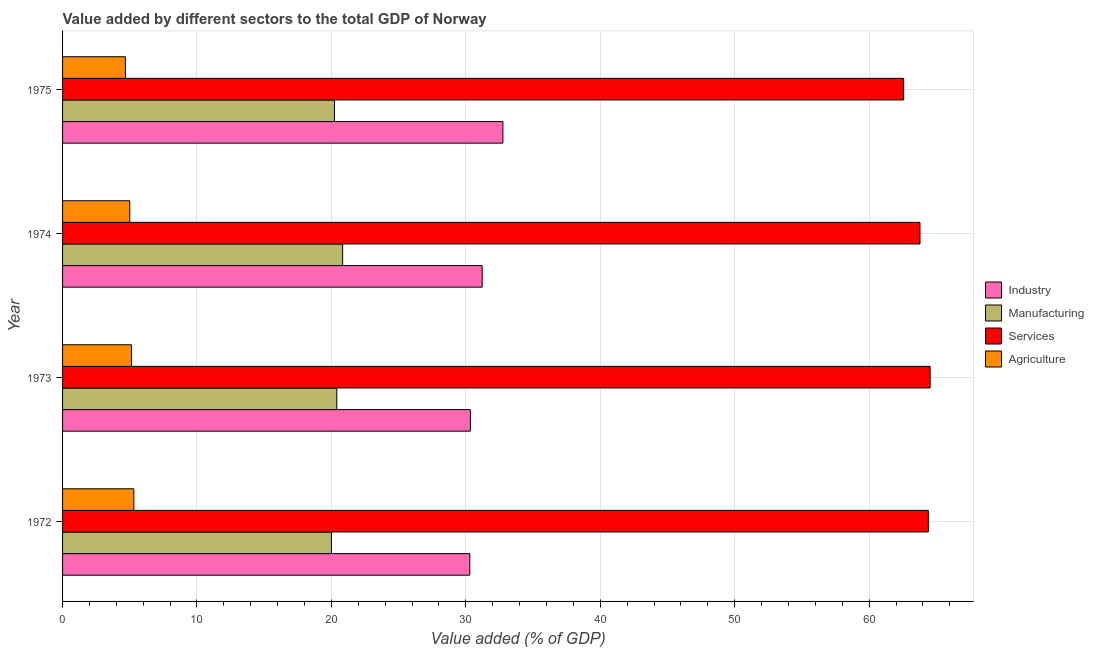How many groups of bars are there?
Provide a succinct answer. 4. Are the number of bars per tick equal to the number of legend labels?
Offer a terse response. Yes. Are the number of bars on each tick of the Y-axis equal?
Offer a very short reply. Yes. What is the label of the 1st group of bars from the top?
Give a very brief answer. 1975. In how many cases, is the number of bars for a given year not equal to the number of legend labels?
Your answer should be compact. 0. What is the value added by services sector in 1974?
Give a very brief answer. 63.79. Across all years, what is the maximum value added by agricultural sector?
Your answer should be very brief. 5.3. Across all years, what is the minimum value added by services sector?
Offer a terse response. 62.57. In which year was the value added by industrial sector maximum?
Provide a short and direct response. 1975. In which year was the value added by agricultural sector minimum?
Your response must be concise. 1975. What is the total value added by manufacturing sector in the graph?
Offer a terse response. 81.47. What is the difference between the value added by industrial sector in 1972 and that in 1975?
Offer a very short reply. -2.46. What is the difference between the value added by agricultural sector in 1973 and the value added by services sector in 1975?
Offer a terse response. -57.44. What is the average value added by services sector per year?
Your response must be concise. 63.83. In the year 1974, what is the difference between the value added by industrial sector and value added by agricultural sector?
Your response must be concise. 26.22. In how many years, is the value added by services sector greater than 50 %?
Provide a short and direct response. 4. Is the value added by services sector in 1974 less than that in 1975?
Provide a succinct answer. No. Is the difference between the value added by manufacturing sector in 1973 and 1975 greater than the difference between the value added by services sector in 1973 and 1975?
Offer a very short reply. No. What is the difference between the highest and the second highest value added by agricultural sector?
Make the answer very short. 0.18. What is the difference between the highest and the lowest value added by services sector?
Your answer should be compact. 1.97. In how many years, is the value added by manufacturing sector greater than the average value added by manufacturing sector taken over all years?
Provide a short and direct response. 2. Is the sum of the value added by agricultural sector in 1972 and 1974 greater than the maximum value added by manufacturing sector across all years?
Offer a terse response. No. What does the 4th bar from the top in 1972 represents?
Give a very brief answer. Industry. What does the 1st bar from the bottom in 1973 represents?
Give a very brief answer. Industry. How many bars are there?
Provide a short and direct response. 16. What is the difference between two consecutive major ticks on the X-axis?
Give a very brief answer. 10. Are the values on the major ticks of X-axis written in scientific E-notation?
Make the answer very short. No. Where does the legend appear in the graph?
Ensure brevity in your answer.  Center right. How are the legend labels stacked?
Provide a short and direct response. Vertical. What is the title of the graph?
Make the answer very short. Value added by different sectors to the total GDP of Norway. What is the label or title of the X-axis?
Keep it short and to the point. Value added (% of GDP). What is the Value added (% of GDP) of Industry in 1972?
Your answer should be very brief. 30.29. What is the Value added (% of GDP) in Manufacturing in 1972?
Make the answer very short. 20. What is the Value added (% of GDP) in Services in 1972?
Your answer should be very brief. 64.41. What is the Value added (% of GDP) of Agriculture in 1972?
Make the answer very short. 5.3. What is the Value added (% of GDP) of Industry in 1973?
Offer a very short reply. 30.34. What is the Value added (% of GDP) in Manufacturing in 1973?
Make the answer very short. 20.4. What is the Value added (% of GDP) in Services in 1973?
Provide a succinct answer. 64.54. What is the Value added (% of GDP) of Agriculture in 1973?
Provide a succinct answer. 5.12. What is the Value added (% of GDP) in Industry in 1974?
Your answer should be very brief. 31.22. What is the Value added (% of GDP) in Manufacturing in 1974?
Your response must be concise. 20.83. What is the Value added (% of GDP) in Services in 1974?
Ensure brevity in your answer.  63.79. What is the Value added (% of GDP) of Agriculture in 1974?
Offer a very short reply. 5. What is the Value added (% of GDP) in Industry in 1975?
Ensure brevity in your answer.  32.76. What is the Value added (% of GDP) in Manufacturing in 1975?
Provide a succinct answer. 20.23. What is the Value added (% of GDP) of Services in 1975?
Your response must be concise. 62.57. What is the Value added (% of GDP) in Agriculture in 1975?
Make the answer very short. 4.67. Across all years, what is the maximum Value added (% of GDP) in Industry?
Offer a terse response. 32.76. Across all years, what is the maximum Value added (% of GDP) in Manufacturing?
Make the answer very short. 20.83. Across all years, what is the maximum Value added (% of GDP) of Services?
Ensure brevity in your answer.  64.54. Across all years, what is the maximum Value added (% of GDP) in Agriculture?
Provide a succinct answer. 5.3. Across all years, what is the minimum Value added (% of GDP) of Industry?
Offer a terse response. 30.29. Across all years, what is the minimum Value added (% of GDP) of Manufacturing?
Your answer should be very brief. 20. Across all years, what is the minimum Value added (% of GDP) of Services?
Make the answer very short. 62.57. Across all years, what is the minimum Value added (% of GDP) in Agriculture?
Your response must be concise. 4.67. What is the total Value added (% of GDP) in Industry in the graph?
Ensure brevity in your answer.  124.6. What is the total Value added (% of GDP) of Manufacturing in the graph?
Your response must be concise. 81.47. What is the total Value added (% of GDP) in Services in the graph?
Make the answer very short. 255.3. What is the total Value added (% of GDP) of Agriculture in the graph?
Keep it short and to the point. 20.1. What is the difference between the Value added (% of GDP) of Industry in 1972 and that in 1973?
Keep it short and to the point. -0.04. What is the difference between the Value added (% of GDP) in Manufacturing in 1972 and that in 1973?
Give a very brief answer. -0.4. What is the difference between the Value added (% of GDP) in Services in 1972 and that in 1973?
Give a very brief answer. -0.13. What is the difference between the Value added (% of GDP) of Agriculture in 1972 and that in 1973?
Provide a short and direct response. 0.18. What is the difference between the Value added (% of GDP) of Industry in 1972 and that in 1974?
Your answer should be compact. -0.92. What is the difference between the Value added (% of GDP) in Manufacturing in 1972 and that in 1974?
Provide a short and direct response. -0.83. What is the difference between the Value added (% of GDP) in Services in 1972 and that in 1974?
Make the answer very short. 0.62. What is the difference between the Value added (% of GDP) in Agriculture in 1972 and that in 1974?
Your response must be concise. 0.3. What is the difference between the Value added (% of GDP) in Industry in 1972 and that in 1975?
Give a very brief answer. -2.46. What is the difference between the Value added (% of GDP) in Manufacturing in 1972 and that in 1975?
Keep it short and to the point. -0.22. What is the difference between the Value added (% of GDP) in Services in 1972 and that in 1975?
Your answer should be compact. 1.84. What is the difference between the Value added (% of GDP) in Agriculture in 1972 and that in 1975?
Provide a succinct answer. 0.63. What is the difference between the Value added (% of GDP) of Industry in 1973 and that in 1974?
Offer a terse response. -0.88. What is the difference between the Value added (% of GDP) of Manufacturing in 1973 and that in 1974?
Make the answer very short. -0.43. What is the difference between the Value added (% of GDP) of Services in 1973 and that in 1974?
Make the answer very short. 0.75. What is the difference between the Value added (% of GDP) in Agriculture in 1973 and that in 1974?
Make the answer very short. 0.12. What is the difference between the Value added (% of GDP) of Industry in 1973 and that in 1975?
Give a very brief answer. -2.42. What is the difference between the Value added (% of GDP) of Manufacturing in 1973 and that in 1975?
Ensure brevity in your answer.  0.17. What is the difference between the Value added (% of GDP) of Services in 1973 and that in 1975?
Your answer should be very brief. 1.97. What is the difference between the Value added (% of GDP) in Agriculture in 1973 and that in 1975?
Provide a succinct answer. 0.45. What is the difference between the Value added (% of GDP) of Industry in 1974 and that in 1975?
Your answer should be very brief. -1.54. What is the difference between the Value added (% of GDP) in Manufacturing in 1974 and that in 1975?
Offer a very short reply. 0.61. What is the difference between the Value added (% of GDP) in Services in 1974 and that in 1975?
Make the answer very short. 1.22. What is the difference between the Value added (% of GDP) of Agriculture in 1974 and that in 1975?
Your response must be concise. 0.32. What is the difference between the Value added (% of GDP) in Industry in 1972 and the Value added (% of GDP) in Manufacturing in 1973?
Your response must be concise. 9.89. What is the difference between the Value added (% of GDP) of Industry in 1972 and the Value added (% of GDP) of Services in 1973?
Your response must be concise. -34.25. What is the difference between the Value added (% of GDP) of Industry in 1972 and the Value added (% of GDP) of Agriculture in 1973?
Your answer should be very brief. 25.17. What is the difference between the Value added (% of GDP) of Manufacturing in 1972 and the Value added (% of GDP) of Services in 1973?
Offer a terse response. -44.54. What is the difference between the Value added (% of GDP) in Manufacturing in 1972 and the Value added (% of GDP) in Agriculture in 1973?
Provide a short and direct response. 14.88. What is the difference between the Value added (% of GDP) of Services in 1972 and the Value added (% of GDP) of Agriculture in 1973?
Ensure brevity in your answer.  59.28. What is the difference between the Value added (% of GDP) in Industry in 1972 and the Value added (% of GDP) in Manufacturing in 1974?
Keep it short and to the point. 9.46. What is the difference between the Value added (% of GDP) of Industry in 1972 and the Value added (% of GDP) of Services in 1974?
Provide a succinct answer. -33.49. What is the difference between the Value added (% of GDP) in Industry in 1972 and the Value added (% of GDP) in Agriculture in 1974?
Offer a very short reply. 25.29. What is the difference between the Value added (% of GDP) in Manufacturing in 1972 and the Value added (% of GDP) in Services in 1974?
Your answer should be compact. -43.78. What is the difference between the Value added (% of GDP) in Manufacturing in 1972 and the Value added (% of GDP) in Agriculture in 1974?
Ensure brevity in your answer.  15. What is the difference between the Value added (% of GDP) of Services in 1972 and the Value added (% of GDP) of Agriculture in 1974?
Provide a succinct answer. 59.41. What is the difference between the Value added (% of GDP) of Industry in 1972 and the Value added (% of GDP) of Manufacturing in 1975?
Provide a short and direct response. 10.07. What is the difference between the Value added (% of GDP) of Industry in 1972 and the Value added (% of GDP) of Services in 1975?
Keep it short and to the point. -32.27. What is the difference between the Value added (% of GDP) in Industry in 1972 and the Value added (% of GDP) in Agriculture in 1975?
Ensure brevity in your answer.  25.62. What is the difference between the Value added (% of GDP) of Manufacturing in 1972 and the Value added (% of GDP) of Services in 1975?
Give a very brief answer. -42.56. What is the difference between the Value added (% of GDP) in Manufacturing in 1972 and the Value added (% of GDP) in Agriculture in 1975?
Your response must be concise. 15.33. What is the difference between the Value added (% of GDP) of Services in 1972 and the Value added (% of GDP) of Agriculture in 1975?
Your answer should be compact. 59.73. What is the difference between the Value added (% of GDP) in Industry in 1973 and the Value added (% of GDP) in Manufacturing in 1974?
Your answer should be compact. 9.5. What is the difference between the Value added (% of GDP) in Industry in 1973 and the Value added (% of GDP) in Services in 1974?
Your response must be concise. -33.45. What is the difference between the Value added (% of GDP) in Industry in 1973 and the Value added (% of GDP) in Agriculture in 1974?
Your response must be concise. 25.34. What is the difference between the Value added (% of GDP) of Manufacturing in 1973 and the Value added (% of GDP) of Services in 1974?
Your answer should be very brief. -43.38. What is the difference between the Value added (% of GDP) in Manufacturing in 1973 and the Value added (% of GDP) in Agriculture in 1974?
Provide a succinct answer. 15.4. What is the difference between the Value added (% of GDP) in Services in 1973 and the Value added (% of GDP) in Agriculture in 1974?
Give a very brief answer. 59.54. What is the difference between the Value added (% of GDP) in Industry in 1973 and the Value added (% of GDP) in Manufacturing in 1975?
Your response must be concise. 10.11. What is the difference between the Value added (% of GDP) of Industry in 1973 and the Value added (% of GDP) of Services in 1975?
Your response must be concise. -32.23. What is the difference between the Value added (% of GDP) in Industry in 1973 and the Value added (% of GDP) in Agriculture in 1975?
Make the answer very short. 25.66. What is the difference between the Value added (% of GDP) of Manufacturing in 1973 and the Value added (% of GDP) of Services in 1975?
Provide a short and direct response. -42.17. What is the difference between the Value added (% of GDP) in Manufacturing in 1973 and the Value added (% of GDP) in Agriculture in 1975?
Ensure brevity in your answer.  15.73. What is the difference between the Value added (% of GDP) of Services in 1973 and the Value added (% of GDP) of Agriculture in 1975?
Provide a short and direct response. 59.86. What is the difference between the Value added (% of GDP) in Industry in 1974 and the Value added (% of GDP) in Manufacturing in 1975?
Offer a very short reply. 10.99. What is the difference between the Value added (% of GDP) in Industry in 1974 and the Value added (% of GDP) in Services in 1975?
Your answer should be compact. -31.35. What is the difference between the Value added (% of GDP) of Industry in 1974 and the Value added (% of GDP) of Agriculture in 1975?
Provide a succinct answer. 26.54. What is the difference between the Value added (% of GDP) in Manufacturing in 1974 and the Value added (% of GDP) in Services in 1975?
Provide a short and direct response. -41.73. What is the difference between the Value added (% of GDP) in Manufacturing in 1974 and the Value added (% of GDP) in Agriculture in 1975?
Give a very brief answer. 16.16. What is the difference between the Value added (% of GDP) in Services in 1974 and the Value added (% of GDP) in Agriculture in 1975?
Make the answer very short. 59.11. What is the average Value added (% of GDP) of Industry per year?
Ensure brevity in your answer.  31.15. What is the average Value added (% of GDP) in Manufacturing per year?
Your response must be concise. 20.37. What is the average Value added (% of GDP) in Services per year?
Keep it short and to the point. 63.82. What is the average Value added (% of GDP) in Agriculture per year?
Give a very brief answer. 5.02. In the year 1972, what is the difference between the Value added (% of GDP) of Industry and Value added (% of GDP) of Manufacturing?
Keep it short and to the point. 10.29. In the year 1972, what is the difference between the Value added (% of GDP) in Industry and Value added (% of GDP) in Services?
Your answer should be compact. -34.11. In the year 1972, what is the difference between the Value added (% of GDP) of Industry and Value added (% of GDP) of Agriculture?
Make the answer very short. 24.99. In the year 1972, what is the difference between the Value added (% of GDP) in Manufacturing and Value added (% of GDP) in Services?
Provide a succinct answer. -44.4. In the year 1972, what is the difference between the Value added (% of GDP) of Manufacturing and Value added (% of GDP) of Agriculture?
Provide a short and direct response. 14.7. In the year 1972, what is the difference between the Value added (% of GDP) in Services and Value added (% of GDP) in Agriculture?
Keep it short and to the point. 59.11. In the year 1973, what is the difference between the Value added (% of GDP) in Industry and Value added (% of GDP) in Manufacturing?
Provide a succinct answer. 9.94. In the year 1973, what is the difference between the Value added (% of GDP) of Industry and Value added (% of GDP) of Services?
Offer a very short reply. -34.2. In the year 1973, what is the difference between the Value added (% of GDP) of Industry and Value added (% of GDP) of Agriculture?
Offer a terse response. 25.21. In the year 1973, what is the difference between the Value added (% of GDP) of Manufacturing and Value added (% of GDP) of Services?
Ensure brevity in your answer.  -44.14. In the year 1973, what is the difference between the Value added (% of GDP) of Manufacturing and Value added (% of GDP) of Agriculture?
Make the answer very short. 15.28. In the year 1973, what is the difference between the Value added (% of GDP) of Services and Value added (% of GDP) of Agriculture?
Your answer should be compact. 59.42. In the year 1974, what is the difference between the Value added (% of GDP) in Industry and Value added (% of GDP) in Manufacturing?
Provide a short and direct response. 10.38. In the year 1974, what is the difference between the Value added (% of GDP) of Industry and Value added (% of GDP) of Services?
Give a very brief answer. -32.57. In the year 1974, what is the difference between the Value added (% of GDP) of Industry and Value added (% of GDP) of Agriculture?
Ensure brevity in your answer.  26.22. In the year 1974, what is the difference between the Value added (% of GDP) in Manufacturing and Value added (% of GDP) in Services?
Make the answer very short. -42.95. In the year 1974, what is the difference between the Value added (% of GDP) of Manufacturing and Value added (% of GDP) of Agriculture?
Your response must be concise. 15.84. In the year 1974, what is the difference between the Value added (% of GDP) of Services and Value added (% of GDP) of Agriculture?
Provide a short and direct response. 58.79. In the year 1975, what is the difference between the Value added (% of GDP) of Industry and Value added (% of GDP) of Manufacturing?
Your answer should be very brief. 12.53. In the year 1975, what is the difference between the Value added (% of GDP) in Industry and Value added (% of GDP) in Services?
Provide a succinct answer. -29.81. In the year 1975, what is the difference between the Value added (% of GDP) of Industry and Value added (% of GDP) of Agriculture?
Provide a short and direct response. 28.08. In the year 1975, what is the difference between the Value added (% of GDP) in Manufacturing and Value added (% of GDP) in Services?
Ensure brevity in your answer.  -42.34. In the year 1975, what is the difference between the Value added (% of GDP) in Manufacturing and Value added (% of GDP) in Agriculture?
Give a very brief answer. 15.55. In the year 1975, what is the difference between the Value added (% of GDP) in Services and Value added (% of GDP) in Agriculture?
Ensure brevity in your answer.  57.89. What is the ratio of the Value added (% of GDP) of Manufacturing in 1972 to that in 1973?
Offer a terse response. 0.98. What is the ratio of the Value added (% of GDP) of Agriculture in 1972 to that in 1973?
Your response must be concise. 1.03. What is the ratio of the Value added (% of GDP) of Industry in 1972 to that in 1974?
Provide a short and direct response. 0.97. What is the ratio of the Value added (% of GDP) in Manufacturing in 1972 to that in 1974?
Your answer should be very brief. 0.96. What is the ratio of the Value added (% of GDP) of Services in 1972 to that in 1974?
Provide a succinct answer. 1.01. What is the ratio of the Value added (% of GDP) of Agriculture in 1972 to that in 1974?
Provide a succinct answer. 1.06. What is the ratio of the Value added (% of GDP) in Industry in 1972 to that in 1975?
Keep it short and to the point. 0.92. What is the ratio of the Value added (% of GDP) in Services in 1972 to that in 1975?
Provide a short and direct response. 1.03. What is the ratio of the Value added (% of GDP) in Agriculture in 1972 to that in 1975?
Ensure brevity in your answer.  1.13. What is the ratio of the Value added (% of GDP) in Industry in 1973 to that in 1974?
Provide a succinct answer. 0.97. What is the ratio of the Value added (% of GDP) of Manufacturing in 1973 to that in 1974?
Your answer should be compact. 0.98. What is the ratio of the Value added (% of GDP) of Services in 1973 to that in 1974?
Make the answer very short. 1.01. What is the ratio of the Value added (% of GDP) in Agriculture in 1973 to that in 1974?
Your answer should be very brief. 1.02. What is the ratio of the Value added (% of GDP) of Industry in 1973 to that in 1975?
Your answer should be compact. 0.93. What is the ratio of the Value added (% of GDP) in Manufacturing in 1973 to that in 1975?
Offer a terse response. 1.01. What is the ratio of the Value added (% of GDP) in Services in 1973 to that in 1975?
Offer a terse response. 1.03. What is the ratio of the Value added (% of GDP) of Agriculture in 1973 to that in 1975?
Your answer should be very brief. 1.1. What is the ratio of the Value added (% of GDP) of Industry in 1974 to that in 1975?
Offer a very short reply. 0.95. What is the ratio of the Value added (% of GDP) of Manufacturing in 1974 to that in 1975?
Make the answer very short. 1.03. What is the ratio of the Value added (% of GDP) in Services in 1974 to that in 1975?
Your answer should be compact. 1.02. What is the ratio of the Value added (% of GDP) in Agriculture in 1974 to that in 1975?
Keep it short and to the point. 1.07. What is the difference between the highest and the second highest Value added (% of GDP) of Industry?
Provide a succinct answer. 1.54. What is the difference between the highest and the second highest Value added (% of GDP) in Manufacturing?
Provide a short and direct response. 0.43. What is the difference between the highest and the second highest Value added (% of GDP) of Services?
Provide a succinct answer. 0.13. What is the difference between the highest and the second highest Value added (% of GDP) of Agriculture?
Keep it short and to the point. 0.18. What is the difference between the highest and the lowest Value added (% of GDP) of Industry?
Offer a terse response. 2.46. What is the difference between the highest and the lowest Value added (% of GDP) in Manufacturing?
Make the answer very short. 0.83. What is the difference between the highest and the lowest Value added (% of GDP) in Services?
Make the answer very short. 1.97. What is the difference between the highest and the lowest Value added (% of GDP) of Agriculture?
Provide a succinct answer. 0.63. 